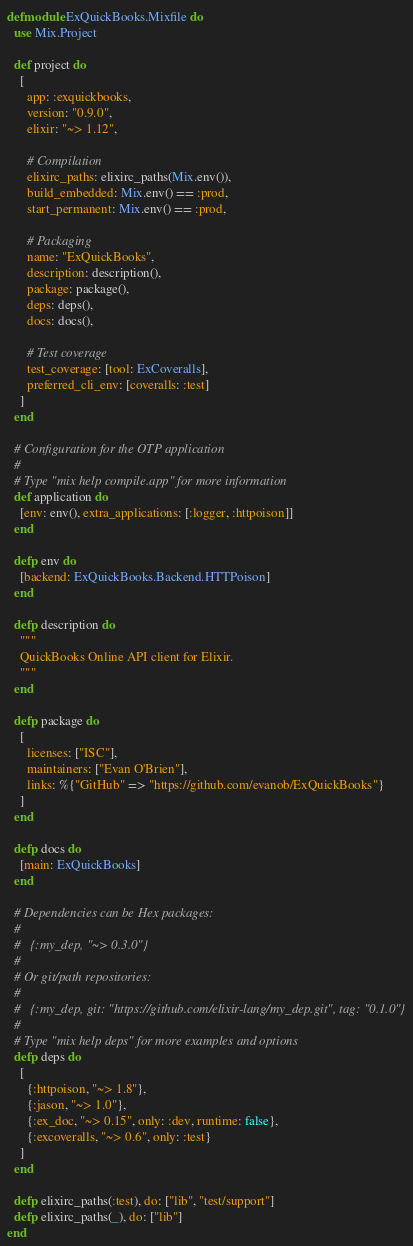Convert code to text. <code><loc_0><loc_0><loc_500><loc_500><_Elixir_>defmodule ExQuickBooks.Mixfile do
  use Mix.Project

  def project do
    [
      app: :exquickbooks,
      version: "0.9.0",
      elixir: "~> 1.12",

      # Compilation
      elixirc_paths: elixirc_paths(Mix.env()),
      build_embedded: Mix.env() == :prod,
      start_permanent: Mix.env() == :prod,

      # Packaging
      name: "ExQuickBooks",
      description: description(),
      package: package(),
      deps: deps(),
      docs: docs(),

      # Test coverage
      test_coverage: [tool: ExCoveralls],
      preferred_cli_env: [coveralls: :test]
    ]
  end

  # Configuration for the OTP application
  #
  # Type "mix help compile.app" for more information
  def application do
    [env: env(), extra_applications: [:logger, :httpoison]]
  end

  defp env do
    [backend: ExQuickBooks.Backend.HTTPoison]
  end

  defp description do
    """
    QuickBooks Online API client for Elixir.
    """
  end

  defp package do
    [
      licenses: ["ISC"],
      maintainers: ["Evan O'Brien"],
      links: %{"GitHub" => "https://github.com/evanob/ExQuickBooks"}
    ]
  end

  defp docs do
    [main: ExQuickBooks]
  end

  # Dependencies can be Hex packages:
  #
  #   {:my_dep, "~> 0.3.0"}
  #
  # Or git/path repositories:
  #
  #   {:my_dep, git: "https://github.com/elixir-lang/my_dep.git", tag: "0.1.0"}
  #
  # Type "mix help deps" for more examples and options
  defp deps do
    [
      {:httpoison, "~> 1.8"},
      {:jason, "~> 1.0"},
      {:ex_doc, "~> 0.15", only: :dev, runtime: false},
      {:excoveralls, "~> 0.6", only: :test}
    ]
  end

  defp elixirc_paths(:test), do: ["lib", "test/support"]
  defp elixirc_paths(_), do: ["lib"]
end
</code> 